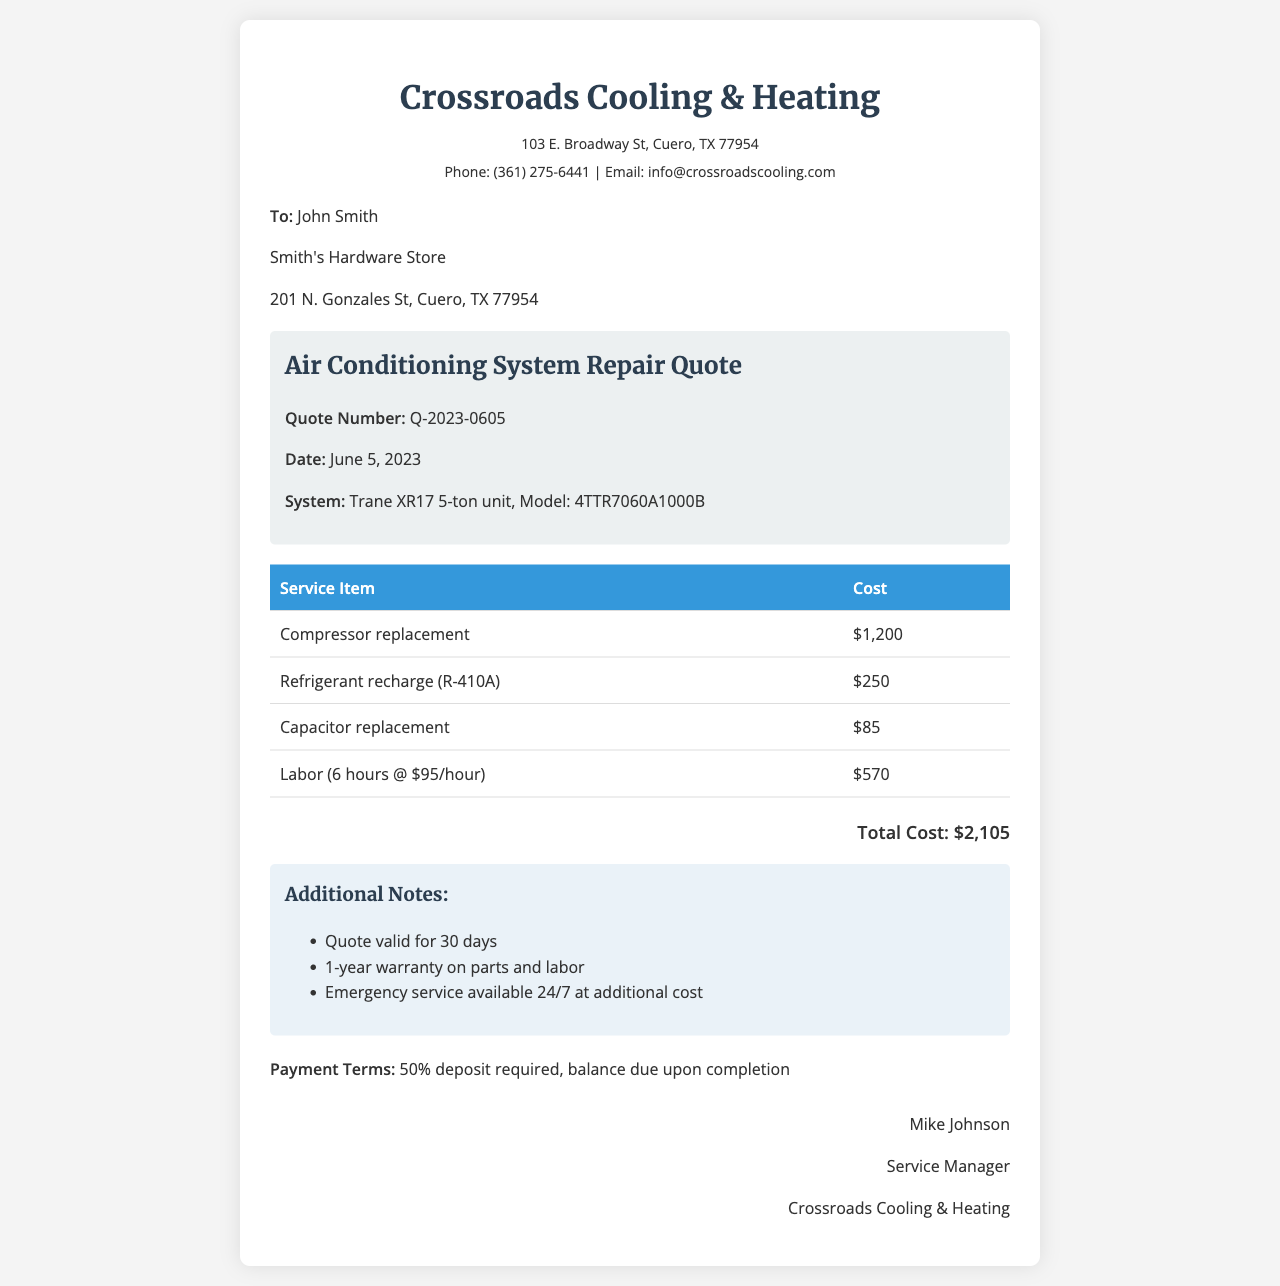What is the quote number? The quote number is listed in the document as Q-2023-0605.
Answer: Q-2023-0605 What is the date of the quote? The date of the quote is clearly marked in the document as June 5, 2023.
Answer: June 5, 2023 Who is the service manager? The service manager's name appears at the end of the document as Mike Johnson.
Answer: Mike Johnson What is the total cost of the services? The total cost is stated in the document and can be found at the bottom of the quote as $2,105.
Answer: $2,105 How long is the quote valid? The quote validity period is mentioned in the additional notes as 30 days.
Answer: 30 days What system is included in the quote? The system is identified in the document as a Trane XR17 5-ton unit, Model: 4TTR7060A1000B.
Answer: Trane XR17 5-ton unit, Model: 4TTR7060A1000B What is the deposit requirement? The payment terms specify that 50% deposit is required before the service is completed.
Answer: 50% deposit How many hours of labor are included? The document states that labor is billed for 6 hours at $95 per hour.
Answer: 6 hours 